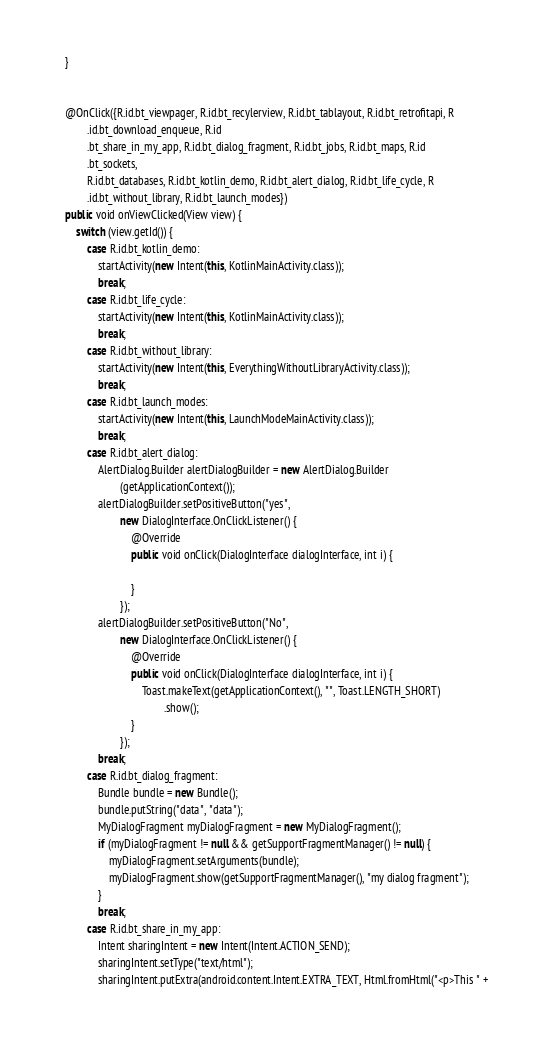Convert code to text. <code><loc_0><loc_0><loc_500><loc_500><_Java_>    }


    @OnClick({R.id.bt_viewpager, R.id.bt_recylerview, R.id.bt_tablayout, R.id.bt_retrofitapi, R
            .id.bt_download_enqueue, R.id
            .bt_share_in_my_app, R.id.bt_dialog_fragment, R.id.bt_jobs, R.id.bt_maps, R.id
            .bt_sockets,
            R.id.bt_databases, R.id.bt_kotlin_demo, R.id.bt_alert_dialog, R.id.bt_life_cycle, R
            .id.bt_without_library, R.id.bt_launch_modes})
    public void onViewClicked(View view) {
        switch (view.getId()) {
            case R.id.bt_kotlin_demo:
                startActivity(new Intent(this, KotlinMainActivity.class));
                break;
            case R.id.bt_life_cycle:
                startActivity(new Intent(this, KotlinMainActivity.class));
                break;
            case R.id.bt_without_library:
                startActivity(new Intent(this, EverythingWithoutLibraryActivity.class));
                break;
            case R.id.bt_launch_modes:
                startActivity(new Intent(this, LaunchModeMainActivity.class));
                break;
            case R.id.bt_alert_dialog:
                AlertDialog.Builder alertDialogBuilder = new AlertDialog.Builder
                        (getApplicationContext());
                alertDialogBuilder.setPositiveButton("yes",
                        new DialogInterface.OnClickListener() {
                            @Override
                            public void onClick(DialogInterface dialogInterface, int i) {

                            }
                        });
                alertDialogBuilder.setPositiveButton("No",
                        new DialogInterface.OnClickListener() {
                            @Override
                            public void onClick(DialogInterface dialogInterface, int i) {
                                Toast.makeText(getApplicationContext(), "", Toast.LENGTH_SHORT)
                                        .show();
                            }
                        });
                break;
            case R.id.bt_dialog_fragment:
                Bundle bundle = new Bundle();
                bundle.putString("data", "data");
                MyDialogFragment myDialogFragment = new MyDialogFragment();
                if (myDialogFragment != null && getSupportFragmentManager() != null) {
                    myDialogFragment.setArguments(bundle);
                    myDialogFragment.show(getSupportFragmentManager(), "my dialog fragment");
                }
                break;
            case R.id.bt_share_in_my_app:
                Intent sharingIntent = new Intent(Intent.ACTION_SEND);
                sharingIntent.setType("text/html");
                sharingIntent.putExtra(android.content.Intent.EXTRA_TEXT, Html.fromHtml("<p>This " +</code> 